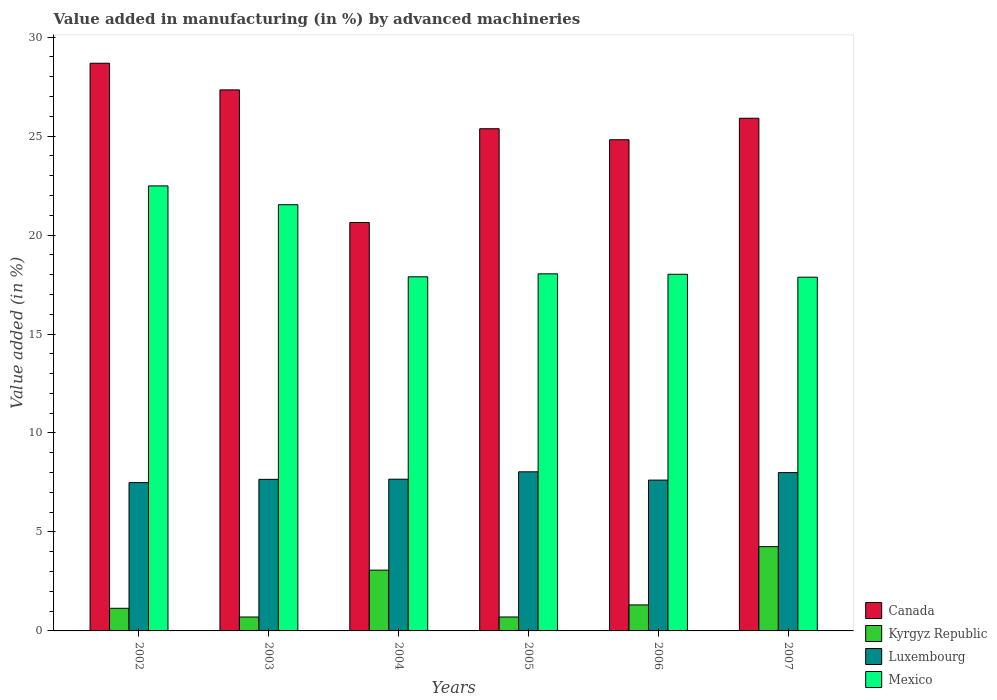How many groups of bars are there?
Keep it short and to the point. 6. What is the label of the 3rd group of bars from the left?
Your answer should be compact. 2004. In how many cases, is the number of bars for a given year not equal to the number of legend labels?
Your answer should be very brief. 0. What is the percentage of value added in manufacturing by advanced machineries in Mexico in 2004?
Your answer should be compact. 17.89. Across all years, what is the maximum percentage of value added in manufacturing by advanced machineries in Luxembourg?
Ensure brevity in your answer.  8.04. Across all years, what is the minimum percentage of value added in manufacturing by advanced machineries in Kyrgyz Republic?
Offer a very short reply. 0.7. In which year was the percentage of value added in manufacturing by advanced machineries in Kyrgyz Republic minimum?
Provide a short and direct response. 2003. What is the total percentage of value added in manufacturing by advanced machineries in Mexico in the graph?
Provide a succinct answer. 115.84. What is the difference between the percentage of value added in manufacturing by advanced machineries in Canada in 2005 and that in 2007?
Ensure brevity in your answer.  -0.53. What is the difference between the percentage of value added in manufacturing by advanced machineries in Mexico in 2006 and the percentage of value added in manufacturing by advanced machineries in Canada in 2004?
Ensure brevity in your answer.  -2.62. What is the average percentage of value added in manufacturing by advanced machineries in Canada per year?
Provide a short and direct response. 25.46. In the year 2004, what is the difference between the percentage of value added in manufacturing by advanced machineries in Canada and percentage of value added in manufacturing by advanced machineries in Mexico?
Offer a terse response. 2.74. In how many years, is the percentage of value added in manufacturing by advanced machineries in Luxembourg greater than 1 %?
Give a very brief answer. 6. What is the ratio of the percentage of value added in manufacturing by advanced machineries in Kyrgyz Republic in 2002 to that in 2005?
Offer a terse response. 1.62. What is the difference between the highest and the second highest percentage of value added in manufacturing by advanced machineries in Luxembourg?
Your response must be concise. 0.04. What is the difference between the highest and the lowest percentage of value added in manufacturing by advanced machineries in Luxembourg?
Your response must be concise. 0.55. In how many years, is the percentage of value added in manufacturing by advanced machineries in Mexico greater than the average percentage of value added in manufacturing by advanced machineries in Mexico taken over all years?
Offer a terse response. 2. Is it the case that in every year, the sum of the percentage of value added in manufacturing by advanced machineries in Mexico and percentage of value added in manufacturing by advanced machineries in Canada is greater than the sum of percentage of value added in manufacturing by advanced machineries in Kyrgyz Republic and percentage of value added in manufacturing by advanced machineries in Luxembourg?
Offer a very short reply. No. What does the 3rd bar from the left in 2007 represents?
Provide a short and direct response. Luxembourg. What does the 3rd bar from the right in 2004 represents?
Offer a terse response. Kyrgyz Republic. Is it the case that in every year, the sum of the percentage of value added in manufacturing by advanced machineries in Luxembourg and percentage of value added in manufacturing by advanced machineries in Canada is greater than the percentage of value added in manufacturing by advanced machineries in Kyrgyz Republic?
Make the answer very short. Yes. How many years are there in the graph?
Provide a succinct answer. 6. How many legend labels are there?
Your response must be concise. 4. How are the legend labels stacked?
Your answer should be compact. Vertical. What is the title of the graph?
Your answer should be compact. Value added in manufacturing (in %) by advanced machineries. Does "Uruguay" appear as one of the legend labels in the graph?
Your response must be concise. No. What is the label or title of the X-axis?
Your response must be concise. Years. What is the label or title of the Y-axis?
Ensure brevity in your answer.  Value added (in %). What is the Value added (in %) in Canada in 2002?
Make the answer very short. 28.68. What is the Value added (in %) of Kyrgyz Republic in 2002?
Offer a very short reply. 1.14. What is the Value added (in %) of Luxembourg in 2002?
Ensure brevity in your answer.  7.49. What is the Value added (in %) of Mexico in 2002?
Keep it short and to the point. 22.48. What is the Value added (in %) of Canada in 2003?
Offer a very short reply. 27.33. What is the Value added (in %) in Kyrgyz Republic in 2003?
Make the answer very short. 0.7. What is the Value added (in %) in Luxembourg in 2003?
Your answer should be compact. 7.66. What is the Value added (in %) of Mexico in 2003?
Your answer should be compact. 21.53. What is the Value added (in %) in Canada in 2004?
Provide a succinct answer. 20.63. What is the Value added (in %) in Kyrgyz Republic in 2004?
Ensure brevity in your answer.  3.07. What is the Value added (in %) in Luxembourg in 2004?
Make the answer very short. 7.67. What is the Value added (in %) in Mexico in 2004?
Provide a succinct answer. 17.89. What is the Value added (in %) of Canada in 2005?
Offer a terse response. 25.37. What is the Value added (in %) in Kyrgyz Republic in 2005?
Offer a very short reply. 0.7. What is the Value added (in %) of Luxembourg in 2005?
Give a very brief answer. 8.04. What is the Value added (in %) in Mexico in 2005?
Offer a very short reply. 18.04. What is the Value added (in %) in Canada in 2006?
Your answer should be compact. 24.81. What is the Value added (in %) of Kyrgyz Republic in 2006?
Your answer should be compact. 1.31. What is the Value added (in %) of Luxembourg in 2006?
Make the answer very short. 7.62. What is the Value added (in %) of Mexico in 2006?
Provide a succinct answer. 18.02. What is the Value added (in %) of Canada in 2007?
Provide a succinct answer. 25.9. What is the Value added (in %) of Kyrgyz Republic in 2007?
Ensure brevity in your answer.  4.26. What is the Value added (in %) in Luxembourg in 2007?
Provide a succinct answer. 8. What is the Value added (in %) in Mexico in 2007?
Make the answer very short. 17.87. Across all years, what is the maximum Value added (in %) in Canada?
Provide a succinct answer. 28.68. Across all years, what is the maximum Value added (in %) of Kyrgyz Republic?
Your response must be concise. 4.26. Across all years, what is the maximum Value added (in %) in Luxembourg?
Ensure brevity in your answer.  8.04. Across all years, what is the maximum Value added (in %) in Mexico?
Keep it short and to the point. 22.48. Across all years, what is the minimum Value added (in %) of Canada?
Make the answer very short. 20.63. Across all years, what is the minimum Value added (in %) in Kyrgyz Republic?
Offer a very short reply. 0.7. Across all years, what is the minimum Value added (in %) in Luxembourg?
Provide a short and direct response. 7.49. Across all years, what is the minimum Value added (in %) in Mexico?
Ensure brevity in your answer.  17.87. What is the total Value added (in %) of Canada in the graph?
Offer a very short reply. 152.73. What is the total Value added (in %) of Kyrgyz Republic in the graph?
Keep it short and to the point. 11.19. What is the total Value added (in %) in Luxembourg in the graph?
Your answer should be compact. 46.47. What is the total Value added (in %) in Mexico in the graph?
Offer a terse response. 115.84. What is the difference between the Value added (in %) of Canada in 2002 and that in 2003?
Make the answer very short. 1.35. What is the difference between the Value added (in %) of Kyrgyz Republic in 2002 and that in 2003?
Make the answer very short. 0.44. What is the difference between the Value added (in %) of Luxembourg in 2002 and that in 2003?
Provide a short and direct response. -0.17. What is the difference between the Value added (in %) in Mexico in 2002 and that in 2003?
Your answer should be compact. 0.95. What is the difference between the Value added (in %) of Canada in 2002 and that in 2004?
Provide a succinct answer. 8.05. What is the difference between the Value added (in %) in Kyrgyz Republic in 2002 and that in 2004?
Offer a terse response. -1.93. What is the difference between the Value added (in %) of Luxembourg in 2002 and that in 2004?
Keep it short and to the point. -0.17. What is the difference between the Value added (in %) of Mexico in 2002 and that in 2004?
Provide a succinct answer. 4.59. What is the difference between the Value added (in %) of Canada in 2002 and that in 2005?
Your response must be concise. 3.31. What is the difference between the Value added (in %) in Kyrgyz Republic in 2002 and that in 2005?
Offer a terse response. 0.44. What is the difference between the Value added (in %) of Luxembourg in 2002 and that in 2005?
Provide a short and direct response. -0.55. What is the difference between the Value added (in %) of Mexico in 2002 and that in 2005?
Your response must be concise. 4.44. What is the difference between the Value added (in %) of Canada in 2002 and that in 2006?
Ensure brevity in your answer.  3.86. What is the difference between the Value added (in %) of Kyrgyz Republic in 2002 and that in 2006?
Your response must be concise. -0.17. What is the difference between the Value added (in %) of Luxembourg in 2002 and that in 2006?
Make the answer very short. -0.13. What is the difference between the Value added (in %) of Mexico in 2002 and that in 2006?
Offer a terse response. 4.47. What is the difference between the Value added (in %) of Canada in 2002 and that in 2007?
Make the answer very short. 2.78. What is the difference between the Value added (in %) in Kyrgyz Republic in 2002 and that in 2007?
Your answer should be compact. -3.11. What is the difference between the Value added (in %) of Luxembourg in 2002 and that in 2007?
Offer a very short reply. -0.51. What is the difference between the Value added (in %) of Mexico in 2002 and that in 2007?
Give a very brief answer. 4.61. What is the difference between the Value added (in %) of Canada in 2003 and that in 2004?
Your answer should be very brief. 6.7. What is the difference between the Value added (in %) in Kyrgyz Republic in 2003 and that in 2004?
Keep it short and to the point. -2.37. What is the difference between the Value added (in %) in Luxembourg in 2003 and that in 2004?
Your answer should be very brief. -0.01. What is the difference between the Value added (in %) of Mexico in 2003 and that in 2004?
Offer a terse response. 3.64. What is the difference between the Value added (in %) of Canada in 2003 and that in 2005?
Provide a succinct answer. 1.96. What is the difference between the Value added (in %) in Kyrgyz Republic in 2003 and that in 2005?
Your answer should be very brief. -0. What is the difference between the Value added (in %) of Luxembourg in 2003 and that in 2005?
Give a very brief answer. -0.38. What is the difference between the Value added (in %) in Mexico in 2003 and that in 2005?
Provide a succinct answer. 3.49. What is the difference between the Value added (in %) in Canada in 2003 and that in 2006?
Offer a very short reply. 2.52. What is the difference between the Value added (in %) in Kyrgyz Republic in 2003 and that in 2006?
Provide a succinct answer. -0.61. What is the difference between the Value added (in %) in Luxembourg in 2003 and that in 2006?
Offer a terse response. 0.04. What is the difference between the Value added (in %) in Mexico in 2003 and that in 2006?
Your response must be concise. 3.52. What is the difference between the Value added (in %) in Canada in 2003 and that in 2007?
Offer a terse response. 1.43. What is the difference between the Value added (in %) in Kyrgyz Republic in 2003 and that in 2007?
Your answer should be compact. -3.56. What is the difference between the Value added (in %) of Luxembourg in 2003 and that in 2007?
Offer a very short reply. -0.34. What is the difference between the Value added (in %) in Mexico in 2003 and that in 2007?
Ensure brevity in your answer.  3.66. What is the difference between the Value added (in %) in Canada in 2004 and that in 2005?
Make the answer very short. -4.74. What is the difference between the Value added (in %) of Kyrgyz Republic in 2004 and that in 2005?
Give a very brief answer. 2.37. What is the difference between the Value added (in %) of Luxembourg in 2004 and that in 2005?
Keep it short and to the point. -0.37. What is the difference between the Value added (in %) in Mexico in 2004 and that in 2005?
Your response must be concise. -0.15. What is the difference between the Value added (in %) in Canada in 2004 and that in 2006?
Offer a terse response. -4.18. What is the difference between the Value added (in %) in Kyrgyz Republic in 2004 and that in 2006?
Your response must be concise. 1.76. What is the difference between the Value added (in %) of Luxembourg in 2004 and that in 2006?
Your answer should be very brief. 0.05. What is the difference between the Value added (in %) of Mexico in 2004 and that in 2006?
Your response must be concise. -0.13. What is the difference between the Value added (in %) of Canada in 2004 and that in 2007?
Your answer should be compact. -5.27. What is the difference between the Value added (in %) of Kyrgyz Republic in 2004 and that in 2007?
Make the answer very short. -1.19. What is the difference between the Value added (in %) in Mexico in 2004 and that in 2007?
Your answer should be compact. 0.02. What is the difference between the Value added (in %) of Canada in 2005 and that in 2006?
Make the answer very short. 0.56. What is the difference between the Value added (in %) of Kyrgyz Republic in 2005 and that in 2006?
Provide a short and direct response. -0.61. What is the difference between the Value added (in %) in Luxembourg in 2005 and that in 2006?
Make the answer very short. 0.42. What is the difference between the Value added (in %) in Mexico in 2005 and that in 2006?
Your response must be concise. 0.02. What is the difference between the Value added (in %) of Canada in 2005 and that in 2007?
Ensure brevity in your answer.  -0.53. What is the difference between the Value added (in %) of Kyrgyz Republic in 2005 and that in 2007?
Your response must be concise. -3.55. What is the difference between the Value added (in %) in Luxembourg in 2005 and that in 2007?
Your answer should be compact. 0.04. What is the difference between the Value added (in %) of Mexico in 2005 and that in 2007?
Your answer should be very brief. 0.17. What is the difference between the Value added (in %) in Canada in 2006 and that in 2007?
Give a very brief answer. -1.09. What is the difference between the Value added (in %) of Kyrgyz Republic in 2006 and that in 2007?
Offer a very short reply. -2.94. What is the difference between the Value added (in %) of Luxembourg in 2006 and that in 2007?
Ensure brevity in your answer.  -0.38. What is the difference between the Value added (in %) in Mexico in 2006 and that in 2007?
Provide a short and direct response. 0.15. What is the difference between the Value added (in %) in Canada in 2002 and the Value added (in %) in Kyrgyz Republic in 2003?
Keep it short and to the point. 27.98. What is the difference between the Value added (in %) in Canada in 2002 and the Value added (in %) in Luxembourg in 2003?
Offer a terse response. 21.02. What is the difference between the Value added (in %) of Canada in 2002 and the Value added (in %) of Mexico in 2003?
Keep it short and to the point. 7.15. What is the difference between the Value added (in %) in Kyrgyz Republic in 2002 and the Value added (in %) in Luxembourg in 2003?
Give a very brief answer. -6.51. What is the difference between the Value added (in %) in Kyrgyz Republic in 2002 and the Value added (in %) in Mexico in 2003?
Your answer should be very brief. -20.39. What is the difference between the Value added (in %) of Luxembourg in 2002 and the Value added (in %) of Mexico in 2003?
Give a very brief answer. -14.04. What is the difference between the Value added (in %) in Canada in 2002 and the Value added (in %) in Kyrgyz Republic in 2004?
Your answer should be very brief. 25.61. What is the difference between the Value added (in %) of Canada in 2002 and the Value added (in %) of Luxembourg in 2004?
Your answer should be compact. 21.01. What is the difference between the Value added (in %) of Canada in 2002 and the Value added (in %) of Mexico in 2004?
Give a very brief answer. 10.79. What is the difference between the Value added (in %) in Kyrgyz Republic in 2002 and the Value added (in %) in Luxembourg in 2004?
Your answer should be very brief. -6.52. What is the difference between the Value added (in %) in Kyrgyz Republic in 2002 and the Value added (in %) in Mexico in 2004?
Make the answer very short. -16.75. What is the difference between the Value added (in %) of Luxembourg in 2002 and the Value added (in %) of Mexico in 2004?
Provide a short and direct response. -10.4. What is the difference between the Value added (in %) of Canada in 2002 and the Value added (in %) of Kyrgyz Republic in 2005?
Provide a short and direct response. 27.98. What is the difference between the Value added (in %) of Canada in 2002 and the Value added (in %) of Luxembourg in 2005?
Provide a short and direct response. 20.64. What is the difference between the Value added (in %) of Canada in 2002 and the Value added (in %) of Mexico in 2005?
Provide a short and direct response. 10.64. What is the difference between the Value added (in %) of Kyrgyz Republic in 2002 and the Value added (in %) of Luxembourg in 2005?
Your response must be concise. -6.9. What is the difference between the Value added (in %) of Kyrgyz Republic in 2002 and the Value added (in %) of Mexico in 2005?
Offer a terse response. -16.9. What is the difference between the Value added (in %) in Luxembourg in 2002 and the Value added (in %) in Mexico in 2005?
Make the answer very short. -10.55. What is the difference between the Value added (in %) of Canada in 2002 and the Value added (in %) of Kyrgyz Republic in 2006?
Keep it short and to the point. 27.37. What is the difference between the Value added (in %) in Canada in 2002 and the Value added (in %) in Luxembourg in 2006?
Make the answer very short. 21.06. What is the difference between the Value added (in %) of Canada in 2002 and the Value added (in %) of Mexico in 2006?
Keep it short and to the point. 10.66. What is the difference between the Value added (in %) in Kyrgyz Republic in 2002 and the Value added (in %) in Luxembourg in 2006?
Give a very brief answer. -6.48. What is the difference between the Value added (in %) in Kyrgyz Republic in 2002 and the Value added (in %) in Mexico in 2006?
Offer a very short reply. -16.87. What is the difference between the Value added (in %) of Luxembourg in 2002 and the Value added (in %) of Mexico in 2006?
Keep it short and to the point. -10.53. What is the difference between the Value added (in %) of Canada in 2002 and the Value added (in %) of Kyrgyz Republic in 2007?
Offer a very short reply. 24.42. What is the difference between the Value added (in %) of Canada in 2002 and the Value added (in %) of Luxembourg in 2007?
Provide a short and direct response. 20.68. What is the difference between the Value added (in %) of Canada in 2002 and the Value added (in %) of Mexico in 2007?
Offer a very short reply. 10.81. What is the difference between the Value added (in %) in Kyrgyz Republic in 2002 and the Value added (in %) in Luxembourg in 2007?
Your response must be concise. -6.86. What is the difference between the Value added (in %) in Kyrgyz Republic in 2002 and the Value added (in %) in Mexico in 2007?
Give a very brief answer. -16.73. What is the difference between the Value added (in %) in Luxembourg in 2002 and the Value added (in %) in Mexico in 2007?
Your answer should be compact. -10.38. What is the difference between the Value added (in %) of Canada in 2003 and the Value added (in %) of Kyrgyz Republic in 2004?
Keep it short and to the point. 24.26. What is the difference between the Value added (in %) in Canada in 2003 and the Value added (in %) in Luxembourg in 2004?
Your answer should be very brief. 19.67. What is the difference between the Value added (in %) in Canada in 2003 and the Value added (in %) in Mexico in 2004?
Provide a short and direct response. 9.44. What is the difference between the Value added (in %) in Kyrgyz Republic in 2003 and the Value added (in %) in Luxembourg in 2004?
Your answer should be very brief. -6.96. What is the difference between the Value added (in %) of Kyrgyz Republic in 2003 and the Value added (in %) of Mexico in 2004?
Keep it short and to the point. -17.19. What is the difference between the Value added (in %) in Luxembourg in 2003 and the Value added (in %) in Mexico in 2004?
Provide a succinct answer. -10.23. What is the difference between the Value added (in %) in Canada in 2003 and the Value added (in %) in Kyrgyz Republic in 2005?
Make the answer very short. 26.63. What is the difference between the Value added (in %) in Canada in 2003 and the Value added (in %) in Luxembourg in 2005?
Offer a very short reply. 19.3. What is the difference between the Value added (in %) of Canada in 2003 and the Value added (in %) of Mexico in 2005?
Your answer should be very brief. 9.29. What is the difference between the Value added (in %) of Kyrgyz Republic in 2003 and the Value added (in %) of Luxembourg in 2005?
Your response must be concise. -7.34. What is the difference between the Value added (in %) of Kyrgyz Republic in 2003 and the Value added (in %) of Mexico in 2005?
Provide a short and direct response. -17.34. What is the difference between the Value added (in %) in Luxembourg in 2003 and the Value added (in %) in Mexico in 2005?
Your answer should be very brief. -10.38. What is the difference between the Value added (in %) in Canada in 2003 and the Value added (in %) in Kyrgyz Republic in 2006?
Your response must be concise. 26.02. What is the difference between the Value added (in %) of Canada in 2003 and the Value added (in %) of Luxembourg in 2006?
Give a very brief answer. 19.71. What is the difference between the Value added (in %) in Canada in 2003 and the Value added (in %) in Mexico in 2006?
Keep it short and to the point. 9.32. What is the difference between the Value added (in %) of Kyrgyz Republic in 2003 and the Value added (in %) of Luxembourg in 2006?
Offer a very short reply. -6.92. What is the difference between the Value added (in %) of Kyrgyz Republic in 2003 and the Value added (in %) of Mexico in 2006?
Provide a short and direct response. -17.32. What is the difference between the Value added (in %) of Luxembourg in 2003 and the Value added (in %) of Mexico in 2006?
Make the answer very short. -10.36. What is the difference between the Value added (in %) of Canada in 2003 and the Value added (in %) of Kyrgyz Republic in 2007?
Give a very brief answer. 23.08. What is the difference between the Value added (in %) of Canada in 2003 and the Value added (in %) of Luxembourg in 2007?
Offer a very short reply. 19.34. What is the difference between the Value added (in %) in Canada in 2003 and the Value added (in %) in Mexico in 2007?
Make the answer very short. 9.46. What is the difference between the Value added (in %) of Kyrgyz Republic in 2003 and the Value added (in %) of Luxembourg in 2007?
Your response must be concise. -7.3. What is the difference between the Value added (in %) of Kyrgyz Republic in 2003 and the Value added (in %) of Mexico in 2007?
Offer a terse response. -17.17. What is the difference between the Value added (in %) of Luxembourg in 2003 and the Value added (in %) of Mexico in 2007?
Your answer should be compact. -10.21. What is the difference between the Value added (in %) of Canada in 2004 and the Value added (in %) of Kyrgyz Republic in 2005?
Your response must be concise. 19.93. What is the difference between the Value added (in %) of Canada in 2004 and the Value added (in %) of Luxembourg in 2005?
Offer a terse response. 12.6. What is the difference between the Value added (in %) in Canada in 2004 and the Value added (in %) in Mexico in 2005?
Your answer should be very brief. 2.59. What is the difference between the Value added (in %) of Kyrgyz Republic in 2004 and the Value added (in %) of Luxembourg in 2005?
Your response must be concise. -4.97. What is the difference between the Value added (in %) of Kyrgyz Republic in 2004 and the Value added (in %) of Mexico in 2005?
Give a very brief answer. -14.97. What is the difference between the Value added (in %) of Luxembourg in 2004 and the Value added (in %) of Mexico in 2005?
Your response must be concise. -10.38. What is the difference between the Value added (in %) in Canada in 2004 and the Value added (in %) in Kyrgyz Republic in 2006?
Offer a very short reply. 19.32. What is the difference between the Value added (in %) of Canada in 2004 and the Value added (in %) of Luxembourg in 2006?
Give a very brief answer. 13.01. What is the difference between the Value added (in %) in Canada in 2004 and the Value added (in %) in Mexico in 2006?
Provide a succinct answer. 2.62. What is the difference between the Value added (in %) of Kyrgyz Republic in 2004 and the Value added (in %) of Luxembourg in 2006?
Ensure brevity in your answer.  -4.55. What is the difference between the Value added (in %) of Kyrgyz Republic in 2004 and the Value added (in %) of Mexico in 2006?
Make the answer very short. -14.95. What is the difference between the Value added (in %) of Luxembourg in 2004 and the Value added (in %) of Mexico in 2006?
Give a very brief answer. -10.35. What is the difference between the Value added (in %) of Canada in 2004 and the Value added (in %) of Kyrgyz Republic in 2007?
Provide a succinct answer. 16.38. What is the difference between the Value added (in %) of Canada in 2004 and the Value added (in %) of Luxembourg in 2007?
Offer a very short reply. 12.64. What is the difference between the Value added (in %) of Canada in 2004 and the Value added (in %) of Mexico in 2007?
Give a very brief answer. 2.76. What is the difference between the Value added (in %) in Kyrgyz Republic in 2004 and the Value added (in %) in Luxembourg in 2007?
Make the answer very short. -4.93. What is the difference between the Value added (in %) in Kyrgyz Republic in 2004 and the Value added (in %) in Mexico in 2007?
Offer a terse response. -14.8. What is the difference between the Value added (in %) of Luxembourg in 2004 and the Value added (in %) of Mexico in 2007?
Offer a very short reply. -10.21. What is the difference between the Value added (in %) of Canada in 2005 and the Value added (in %) of Kyrgyz Republic in 2006?
Ensure brevity in your answer.  24.06. What is the difference between the Value added (in %) in Canada in 2005 and the Value added (in %) in Luxembourg in 2006?
Ensure brevity in your answer.  17.75. What is the difference between the Value added (in %) in Canada in 2005 and the Value added (in %) in Mexico in 2006?
Provide a succinct answer. 7.35. What is the difference between the Value added (in %) of Kyrgyz Republic in 2005 and the Value added (in %) of Luxembourg in 2006?
Give a very brief answer. -6.92. What is the difference between the Value added (in %) of Kyrgyz Republic in 2005 and the Value added (in %) of Mexico in 2006?
Your answer should be compact. -17.31. What is the difference between the Value added (in %) of Luxembourg in 2005 and the Value added (in %) of Mexico in 2006?
Keep it short and to the point. -9.98. What is the difference between the Value added (in %) in Canada in 2005 and the Value added (in %) in Kyrgyz Republic in 2007?
Ensure brevity in your answer.  21.11. What is the difference between the Value added (in %) of Canada in 2005 and the Value added (in %) of Luxembourg in 2007?
Your answer should be very brief. 17.37. What is the difference between the Value added (in %) in Canada in 2005 and the Value added (in %) in Mexico in 2007?
Keep it short and to the point. 7.5. What is the difference between the Value added (in %) of Kyrgyz Republic in 2005 and the Value added (in %) of Luxembourg in 2007?
Make the answer very short. -7.29. What is the difference between the Value added (in %) of Kyrgyz Republic in 2005 and the Value added (in %) of Mexico in 2007?
Provide a short and direct response. -17.17. What is the difference between the Value added (in %) of Luxembourg in 2005 and the Value added (in %) of Mexico in 2007?
Your answer should be very brief. -9.83. What is the difference between the Value added (in %) in Canada in 2006 and the Value added (in %) in Kyrgyz Republic in 2007?
Your response must be concise. 20.56. What is the difference between the Value added (in %) in Canada in 2006 and the Value added (in %) in Luxembourg in 2007?
Make the answer very short. 16.82. What is the difference between the Value added (in %) of Canada in 2006 and the Value added (in %) of Mexico in 2007?
Your answer should be very brief. 6.94. What is the difference between the Value added (in %) in Kyrgyz Republic in 2006 and the Value added (in %) in Luxembourg in 2007?
Offer a terse response. -6.68. What is the difference between the Value added (in %) of Kyrgyz Republic in 2006 and the Value added (in %) of Mexico in 2007?
Make the answer very short. -16.56. What is the difference between the Value added (in %) of Luxembourg in 2006 and the Value added (in %) of Mexico in 2007?
Give a very brief answer. -10.25. What is the average Value added (in %) in Canada per year?
Your answer should be very brief. 25.46. What is the average Value added (in %) of Kyrgyz Republic per year?
Provide a succinct answer. 1.87. What is the average Value added (in %) of Luxembourg per year?
Provide a succinct answer. 7.75. What is the average Value added (in %) in Mexico per year?
Offer a very short reply. 19.31. In the year 2002, what is the difference between the Value added (in %) in Canada and Value added (in %) in Kyrgyz Republic?
Give a very brief answer. 27.54. In the year 2002, what is the difference between the Value added (in %) of Canada and Value added (in %) of Luxembourg?
Your response must be concise. 21.19. In the year 2002, what is the difference between the Value added (in %) in Canada and Value added (in %) in Mexico?
Your answer should be very brief. 6.2. In the year 2002, what is the difference between the Value added (in %) of Kyrgyz Republic and Value added (in %) of Luxembourg?
Provide a succinct answer. -6.35. In the year 2002, what is the difference between the Value added (in %) of Kyrgyz Republic and Value added (in %) of Mexico?
Provide a short and direct response. -21.34. In the year 2002, what is the difference between the Value added (in %) in Luxembourg and Value added (in %) in Mexico?
Give a very brief answer. -14.99. In the year 2003, what is the difference between the Value added (in %) of Canada and Value added (in %) of Kyrgyz Republic?
Keep it short and to the point. 26.63. In the year 2003, what is the difference between the Value added (in %) of Canada and Value added (in %) of Luxembourg?
Offer a terse response. 19.68. In the year 2003, what is the difference between the Value added (in %) of Canada and Value added (in %) of Mexico?
Your answer should be compact. 5.8. In the year 2003, what is the difference between the Value added (in %) in Kyrgyz Republic and Value added (in %) in Luxembourg?
Your answer should be very brief. -6.96. In the year 2003, what is the difference between the Value added (in %) in Kyrgyz Republic and Value added (in %) in Mexico?
Provide a succinct answer. -20.83. In the year 2003, what is the difference between the Value added (in %) in Luxembourg and Value added (in %) in Mexico?
Ensure brevity in your answer.  -13.88. In the year 2004, what is the difference between the Value added (in %) of Canada and Value added (in %) of Kyrgyz Republic?
Your response must be concise. 17.56. In the year 2004, what is the difference between the Value added (in %) in Canada and Value added (in %) in Luxembourg?
Your response must be concise. 12.97. In the year 2004, what is the difference between the Value added (in %) of Canada and Value added (in %) of Mexico?
Your response must be concise. 2.74. In the year 2004, what is the difference between the Value added (in %) in Kyrgyz Republic and Value added (in %) in Luxembourg?
Keep it short and to the point. -4.59. In the year 2004, what is the difference between the Value added (in %) in Kyrgyz Republic and Value added (in %) in Mexico?
Give a very brief answer. -14.82. In the year 2004, what is the difference between the Value added (in %) in Luxembourg and Value added (in %) in Mexico?
Make the answer very short. -10.22. In the year 2005, what is the difference between the Value added (in %) in Canada and Value added (in %) in Kyrgyz Republic?
Your response must be concise. 24.67. In the year 2005, what is the difference between the Value added (in %) of Canada and Value added (in %) of Luxembourg?
Your answer should be very brief. 17.33. In the year 2005, what is the difference between the Value added (in %) in Canada and Value added (in %) in Mexico?
Your answer should be very brief. 7.33. In the year 2005, what is the difference between the Value added (in %) of Kyrgyz Republic and Value added (in %) of Luxembourg?
Provide a succinct answer. -7.33. In the year 2005, what is the difference between the Value added (in %) of Kyrgyz Republic and Value added (in %) of Mexico?
Offer a terse response. -17.34. In the year 2005, what is the difference between the Value added (in %) of Luxembourg and Value added (in %) of Mexico?
Your answer should be very brief. -10. In the year 2006, what is the difference between the Value added (in %) of Canada and Value added (in %) of Kyrgyz Republic?
Provide a short and direct response. 23.5. In the year 2006, what is the difference between the Value added (in %) in Canada and Value added (in %) in Luxembourg?
Your answer should be very brief. 17.19. In the year 2006, what is the difference between the Value added (in %) in Canada and Value added (in %) in Mexico?
Provide a succinct answer. 6.8. In the year 2006, what is the difference between the Value added (in %) in Kyrgyz Republic and Value added (in %) in Luxembourg?
Make the answer very short. -6.31. In the year 2006, what is the difference between the Value added (in %) in Kyrgyz Republic and Value added (in %) in Mexico?
Your answer should be compact. -16.7. In the year 2006, what is the difference between the Value added (in %) in Luxembourg and Value added (in %) in Mexico?
Provide a succinct answer. -10.4. In the year 2007, what is the difference between the Value added (in %) in Canada and Value added (in %) in Kyrgyz Republic?
Offer a very short reply. 21.64. In the year 2007, what is the difference between the Value added (in %) of Canada and Value added (in %) of Luxembourg?
Your answer should be compact. 17.9. In the year 2007, what is the difference between the Value added (in %) in Canada and Value added (in %) in Mexico?
Make the answer very short. 8.03. In the year 2007, what is the difference between the Value added (in %) of Kyrgyz Republic and Value added (in %) of Luxembourg?
Ensure brevity in your answer.  -3.74. In the year 2007, what is the difference between the Value added (in %) in Kyrgyz Republic and Value added (in %) in Mexico?
Your answer should be very brief. -13.61. In the year 2007, what is the difference between the Value added (in %) of Luxembourg and Value added (in %) of Mexico?
Your answer should be compact. -9.87. What is the ratio of the Value added (in %) of Canada in 2002 to that in 2003?
Make the answer very short. 1.05. What is the ratio of the Value added (in %) of Kyrgyz Republic in 2002 to that in 2003?
Your answer should be very brief. 1.63. What is the ratio of the Value added (in %) in Luxembourg in 2002 to that in 2003?
Your answer should be compact. 0.98. What is the ratio of the Value added (in %) in Mexico in 2002 to that in 2003?
Keep it short and to the point. 1.04. What is the ratio of the Value added (in %) of Canada in 2002 to that in 2004?
Offer a terse response. 1.39. What is the ratio of the Value added (in %) of Kyrgyz Republic in 2002 to that in 2004?
Ensure brevity in your answer.  0.37. What is the ratio of the Value added (in %) in Luxembourg in 2002 to that in 2004?
Make the answer very short. 0.98. What is the ratio of the Value added (in %) in Mexico in 2002 to that in 2004?
Your answer should be very brief. 1.26. What is the ratio of the Value added (in %) in Canada in 2002 to that in 2005?
Keep it short and to the point. 1.13. What is the ratio of the Value added (in %) in Kyrgyz Republic in 2002 to that in 2005?
Make the answer very short. 1.62. What is the ratio of the Value added (in %) of Luxembourg in 2002 to that in 2005?
Offer a very short reply. 0.93. What is the ratio of the Value added (in %) in Mexico in 2002 to that in 2005?
Offer a terse response. 1.25. What is the ratio of the Value added (in %) of Canada in 2002 to that in 2006?
Your response must be concise. 1.16. What is the ratio of the Value added (in %) in Kyrgyz Republic in 2002 to that in 2006?
Provide a short and direct response. 0.87. What is the ratio of the Value added (in %) in Luxembourg in 2002 to that in 2006?
Offer a very short reply. 0.98. What is the ratio of the Value added (in %) in Mexico in 2002 to that in 2006?
Ensure brevity in your answer.  1.25. What is the ratio of the Value added (in %) of Canada in 2002 to that in 2007?
Your response must be concise. 1.11. What is the ratio of the Value added (in %) of Kyrgyz Republic in 2002 to that in 2007?
Offer a terse response. 0.27. What is the ratio of the Value added (in %) of Luxembourg in 2002 to that in 2007?
Your response must be concise. 0.94. What is the ratio of the Value added (in %) in Mexico in 2002 to that in 2007?
Provide a succinct answer. 1.26. What is the ratio of the Value added (in %) in Canada in 2003 to that in 2004?
Provide a short and direct response. 1.32. What is the ratio of the Value added (in %) in Kyrgyz Republic in 2003 to that in 2004?
Your answer should be compact. 0.23. What is the ratio of the Value added (in %) of Luxembourg in 2003 to that in 2004?
Offer a terse response. 1. What is the ratio of the Value added (in %) in Mexico in 2003 to that in 2004?
Ensure brevity in your answer.  1.2. What is the ratio of the Value added (in %) of Canada in 2003 to that in 2005?
Your response must be concise. 1.08. What is the ratio of the Value added (in %) in Luxembourg in 2003 to that in 2005?
Your response must be concise. 0.95. What is the ratio of the Value added (in %) of Mexico in 2003 to that in 2005?
Give a very brief answer. 1.19. What is the ratio of the Value added (in %) of Canada in 2003 to that in 2006?
Give a very brief answer. 1.1. What is the ratio of the Value added (in %) of Kyrgyz Republic in 2003 to that in 2006?
Your answer should be compact. 0.53. What is the ratio of the Value added (in %) of Mexico in 2003 to that in 2006?
Make the answer very short. 1.2. What is the ratio of the Value added (in %) of Canada in 2003 to that in 2007?
Give a very brief answer. 1.06. What is the ratio of the Value added (in %) in Kyrgyz Republic in 2003 to that in 2007?
Provide a succinct answer. 0.17. What is the ratio of the Value added (in %) of Luxembourg in 2003 to that in 2007?
Your response must be concise. 0.96. What is the ratio of the Value added (in %) in Mexico in 2003 to that in 2007?
Your answer should be very brief. 1.2. What is the ratio of the Value added (in %) of Canada in 2004 to that in 2005?
Keep it short and to the point. 0.81. What is the ratio of the Value added (in %) of Kyrgyz Republic in 2004 to that in 2005?
Offer a very short reply. 4.36. What is the ratio of the Value added (in %) in Luxembourg in 2004 to that in 2005?
Provide a succinct answer. 0.95. What is the ratio of the Value added (in %) in Canada in 2004 to that in 2006?
Keep it short and to the point. 0.83. What is the ratio of the Value added (in %) of Kyrgyz Republic in 2004 to that in 2006?
Your answer should be very brief. 2.34. What is the ratio of the Value added (in %) in Luxembourg in 2004 to that in 2006?
Give a very brief answer. 1.01. What is the ratio of the Value added (in %) of Canada in 2004 to that in 2007?
Offer a very short reply. 0.8. What is the ratio of the Value added (in %) of Kyrgyz Republic in 2004 to that in 2007?
Keep it short and to the point. 0.72. What is the ratio of the Value added (in %) in Mexico in 2004 to that in 2007?
Provide a short and direct response. 1. What is the ratio of the Value added (in %) of Canada in 2005 to that in 2006?
Your response must be concise. 1.02. What is the ratio of the Value added (in %) in Kyrgyz Republic in 2005 to that in 2006?
Your answer should be very brief. 0.54. What is the ratio of the Value added (in %) in Luxembourg in 2005 to that in 2006?
Keep it short and to the point. 1.05. What is the ratio of the Value added (in %) of Mexico in 2005 to that in 2006?
Give a very brief answer. 1. What is the ratio of the Value added (in %) in Canada in 2005 to that in 2007?
Offer a terse response. 0.98. What is the ratio of the Value added (in %) of Kyrgyz Republic in 2005 to that in 2007?
Your answer should be compact. 0.17. What is the ratio of the Value added (in %) in Mexico in 2005 to that in 2007?
Keep it short and to the point. 1.01. What is the ratio of the Value added (in %) of Canada in 2006 to that in 2007?
Ensure brevity in your answer.  0.96. What is the ratio of the Value added (in %) in Kyrgyz Republic in 2006 to that in 2007?
Make the answer very short. 0.31. What is the ratio of the Value added (in %) in Luxembourg in 2006 to that in 2007?
Make the answer very short. 0.95. What is the ratio of the Value added (in %) in Mexico in 2006 to that in 2007?
Your answer should be compact. 1.01. What is the difference between the highest and the second highest Value added (in %) in Canada?
Your answer should be very brief. 1.35. What is the difference between the highest and the second highest Value added (in %) of Kyrgyz Republic?
Provide a succinct answer. 1.19. What is the difference between the highest and the second highest Value added (in %) of Luxembourg?
Ensure brevity in your answer.  0.04. What is the difference between the highest and the second highest Value added (in %) of Mexico?
Your response must be concise. 0.95. What is the difference between the highest and the lowest Value added (in %) of Canada?
Keep it short and to the point. 8.05. What is the difference between the highest and the lowest Value added (in %) of Kyrgyz Republic?
Your answer should be compact. 3.56. What is the difference between the highest and the lowest Value added (in %) in Luxembourg?
Provide a succinct answer. 0.55. What is the difference between the highest and the lowest Value added (in %) in Mexico?
Your answer should be very brief. 4.61. 